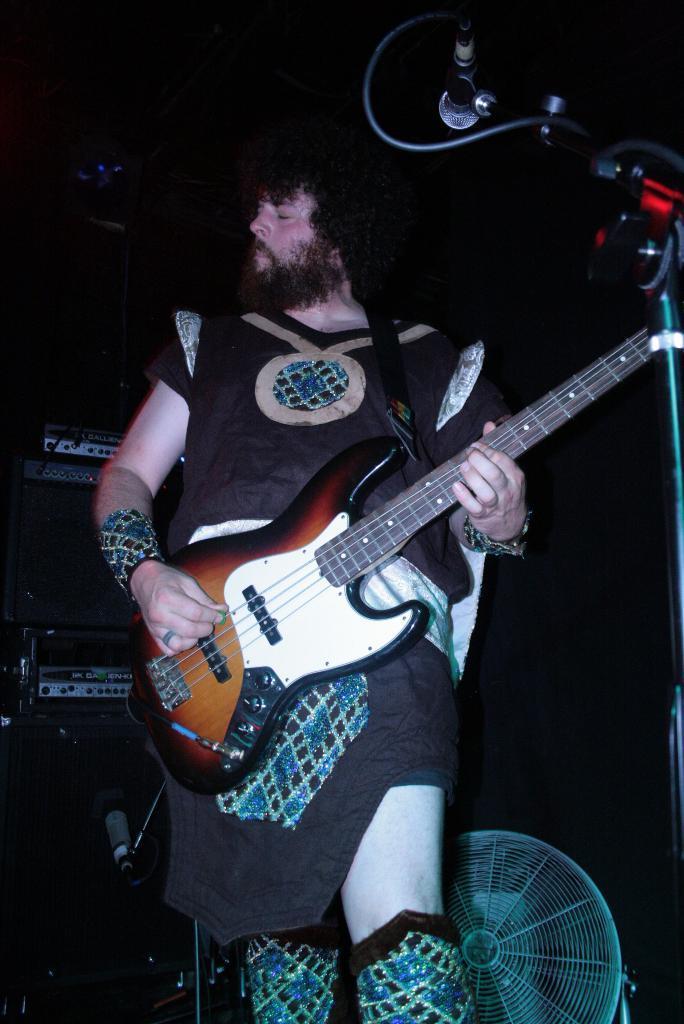How would you summarize this image in a sentence or two? In this Image I can see a man is standing and holding a guitar. I can also see he is wearing a costume. Here I can see a mic. 